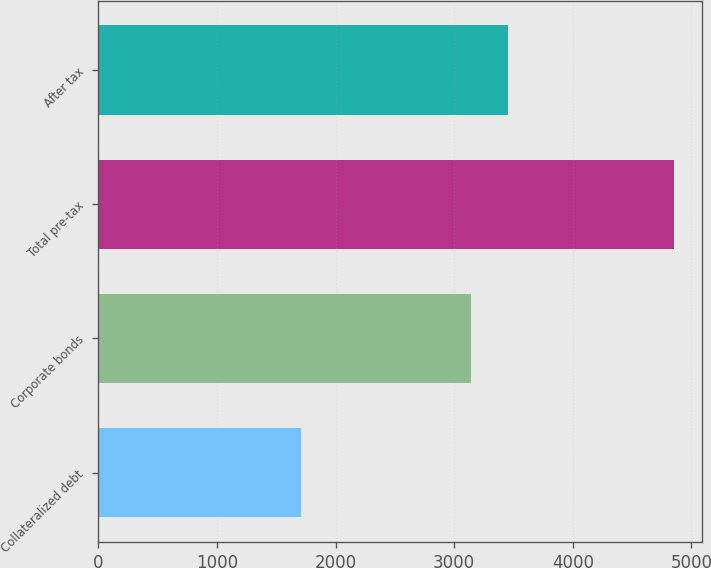<chart> <loc_0><loc_0><loc_500><loc_500><bar_chart><fcel>Collateralized debt<fcel>Corporate bonds<fcel>Total pre-tax<fcel>After tax<nl><fcel>1712<fcel>3138<fcel>4850<fcel>3451.8<nl></chart> 